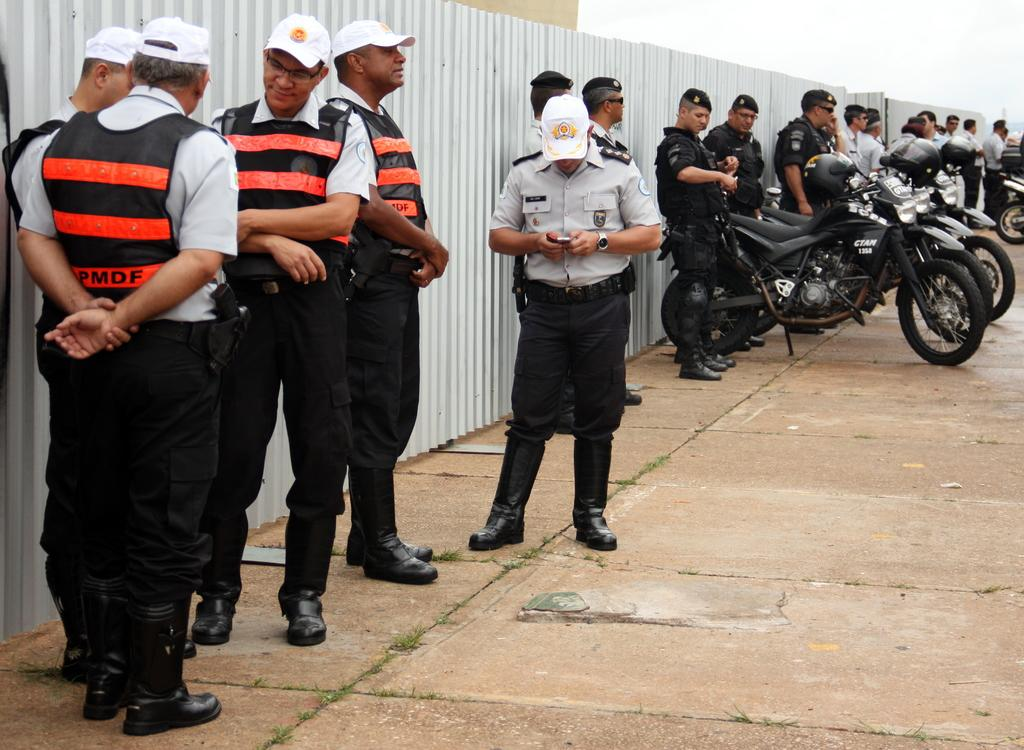How many people are in the image? There is a group of people in the image. What is the person in front wearing? The person in front is wearing a gray shirt and black pants. What can be seen in the background of the image? There are vehicles visible in the background of the image. What is the color of the sky in the image? The sky is visible in the image, and it appears to be white. What type of game is being played by the waves in the image? There are no waves or games present in the image; it features a group of people and vehicles in the background. 